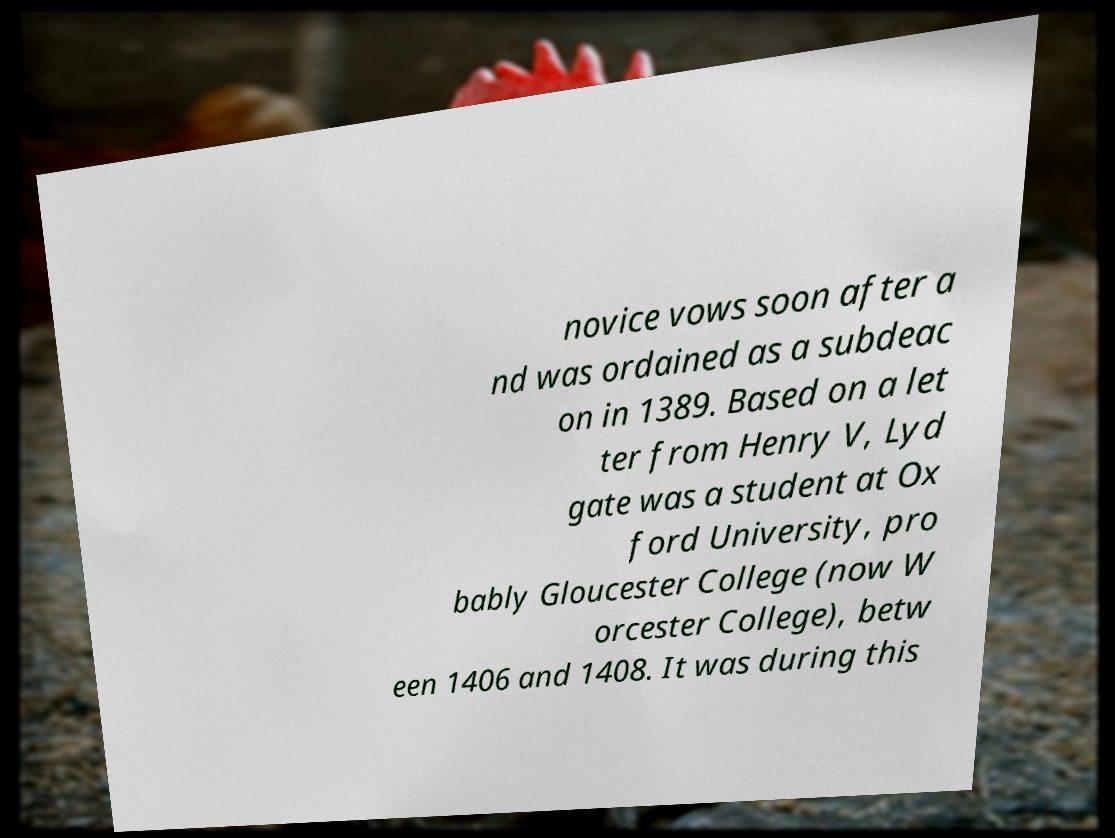For documentation purposes, I need the text within this image transcribed. Could you provide that? novice vows soon after a nd was ordained as a subdeac on in 1389. Based on a let ter from Henry V, Lyd gate was a student at Ox ford University, pro bably Gloucester College (now W orcester College), betw een 1406 and 1408. It was during this 